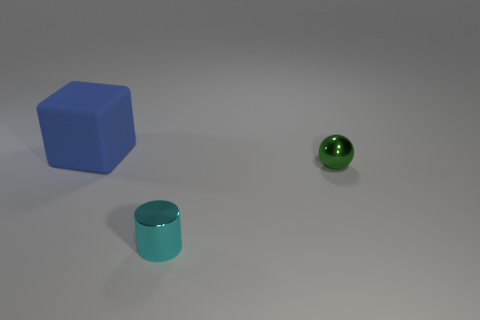What number of things are small things on the left side of the small green shiny ball or objects behind the cyan cylinder?
Ensure brevity in your answer.  3. What is the shape of the cyan object?
Provide a succinct answer. Cylinder. How many balls have the same material as the small cyan thing?
Provide a succinct answer. 1. The tiny metal cylinder has what color?
Keep it short and to the point. Cyan. There is a metallic ball that is the same size as the cyan object; what is its color?
Your response must be concise. Green. Are there any other small metal cylinders of the same color as the metal cylinder?
Your answer should be very brief. No. Does the tiny thing to the right of the cylinder have the same shape as the thing that is left of the small cyan shiny object?
Your answer should be very brief. No. What number of other things are there of the same size as the green sphere?
Ensure brevity in your answer.  1. There is a metal cylinder; is it the same color as the thing that is behind the tiny green metal ball?
Keep it short and to the point. No. Is the number of tiny cyan shiny things right of the tiny green metallic thing less than the number of big things on the left side of the small cyan shiny cylinder?
Provide a succinct answer. Yes. 